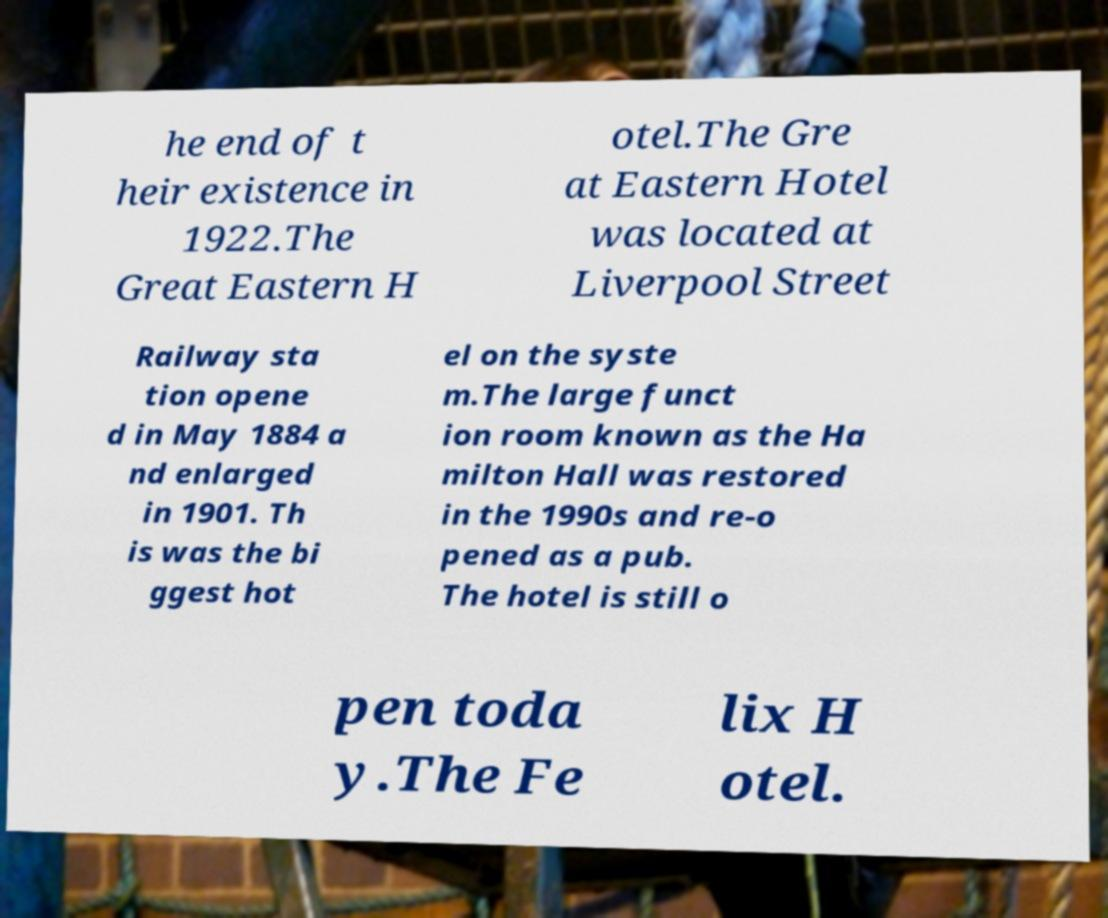Please read and relay the text visible in this image. What does it say? he end of t heir existence in 1922.The Great Eastern H otel.The Gre at Eastern Hotel was located at Liverpool Street Railway sta tion opene d in May 1884 a nd enlarged in 1901. Th is was the bi ggest hot el on the syste m.The large funct ion room known as the Ha milton Hall was restored in the 1990s and re-o pened as a pub. The hotel is still o pen toda y.The Fe lix H otel. 